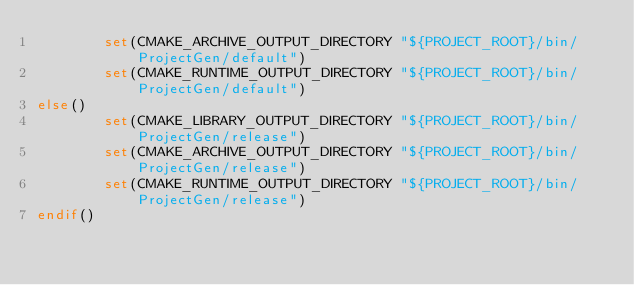<code> <loc_0><loc_0><loc_500><loc_500><_CMake_>        set(CMAKE_ARCHIVE_OUTPUT_DIRECTORY "${PROJECT_ROOT}/bin/ProjectGen/default")
        set(CMAKE_RUNTIME_OUTPUT_DIRECTORY "${PROJECT_ROOT}/bin/ProjectGen/default")
else()
        set(CMAKE_LIBRARY_OUTPUT_DIRECTORY "${PROJECT_ROOT}/bin/ProjectGen/release")
        set(CMAKE_ARCHIVE_OUTPUT_DIRECTORY "${PROJECT_ROOT}/bin/ProjectGen/release")
        set(CMAKE_RUNTIME_OUTPUT_DIRECTORY "${PROJECT_ROOT}/bin/ProjectGen/release")
endif()
</code> 